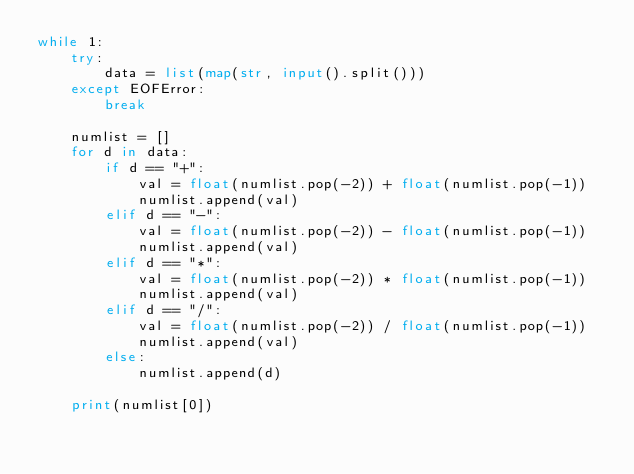<code> <loc_0><loc_0><loc_500><loc_500><_Python_>while 1:
    try:
        data = list(map(str, input().split()))
    except EOFError:
        break

    numlist = []
    for d in data:
        if d == "+":
            val = float(numlist.pop(-2)) + float(numlist.pop(-1))
            numlist.append(val)
        elif d == "-":
            val = float(numlist.pop(-2)) - float(numlist.pop(-1))
            numlist.append(val)
        elif d == "*":
            val = float(numlist.pop(-2)) * float(numlist.pop(-1))
            numlist.append(val)
        elif d == "/":
            val = float(numlist.pop(-2)) / float(numlist.pop(-1))
            numlist.append(val)
        else:
            numlist.append(d)

    print(numlist[0])

</code> 